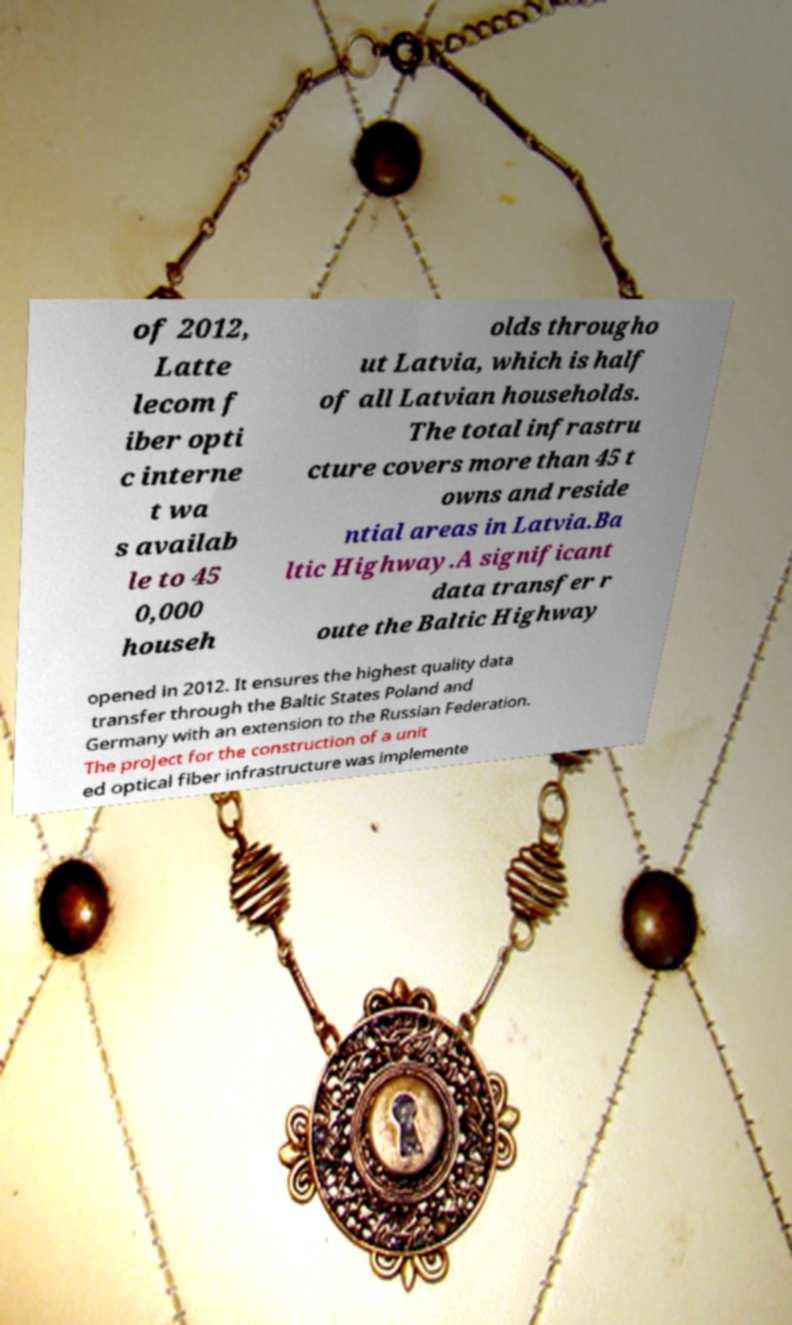Could you assist in decoding the text presented in this image and type it out clearly? of 2012, Latte lecom f iber opti c interne t wa s availab le to 45 0,000 househ olds througho ut Latvia, which is half of all Latvian households. The total infrastru cture covers more than 45 t owns and reside ntial areas in Latvia.Ba ltic Highway.A significant data transfer r oute the Baltic Highway opened in 2012. It ensures the highest quality data transfer through the Baltic States Poland and Germany with an extension to the Russian Federation. The project for the construction of a unit ed optical fiber infrastructure was implemente 